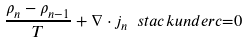<formula> <loc_0><loc_0><loc_500><loc_500>\frac { \rho _ { n } - \rho _ { n - 1 } } T + \nabla \cdot j _ { n } \ s t a c k u n d e r { c } { = } 0</formula> 